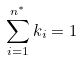<formula> <loc_0><loc_0><loc_500><loc_500>\sum ^ { n ^ { * } } _ { i = 1 } k _ { i } = 1</formula> 